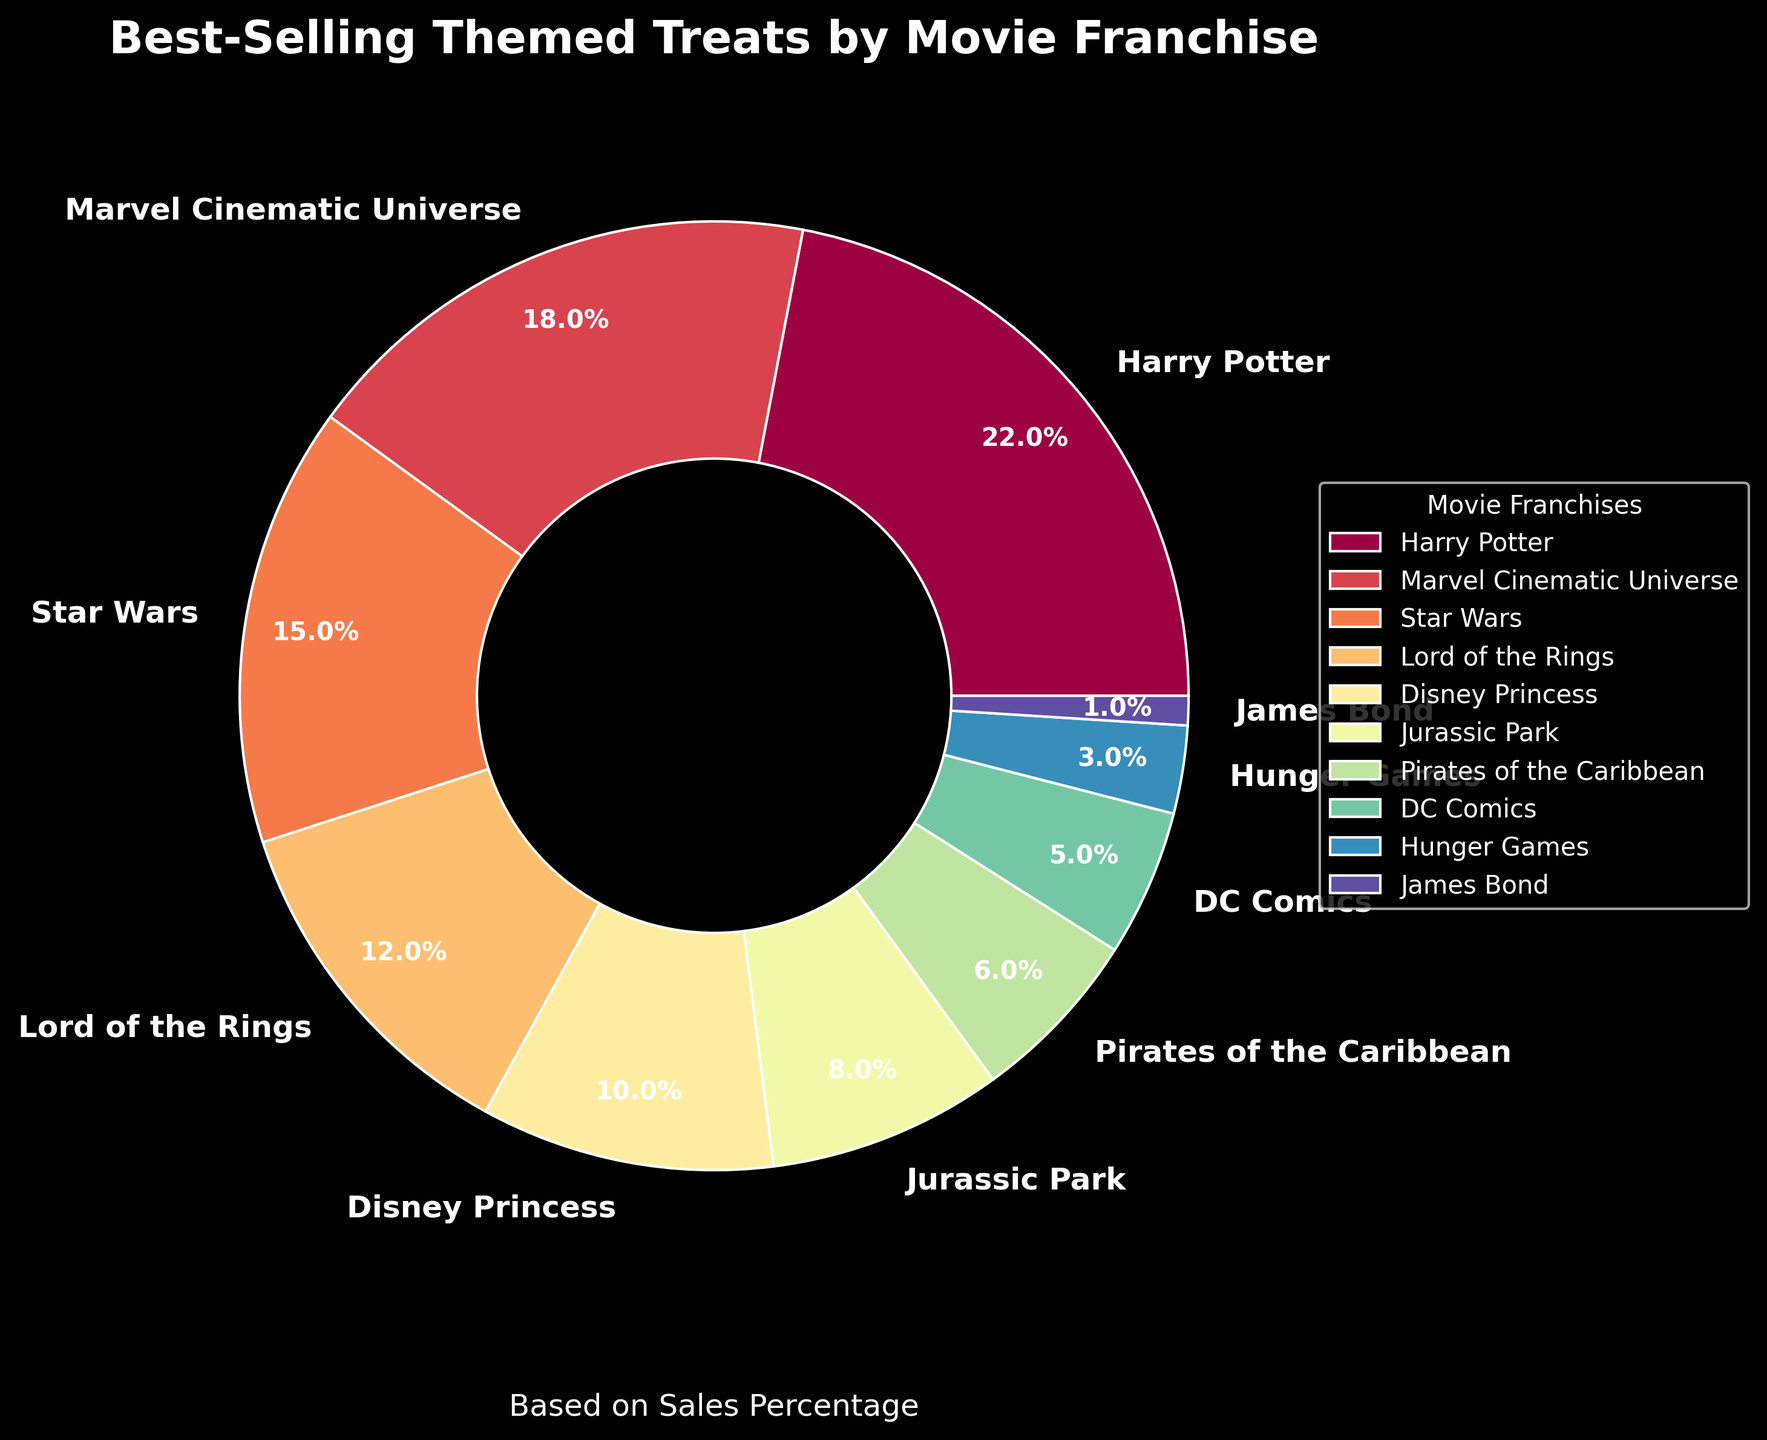Which movie franchise has the highest percentage of best-selling themed treats? The Harry Potter franchise shows the highest percentage in the pie chart, as it occupies the largest wedge.
Answer: Harry Potter Which franchise sells more themed treats, Marvel Cinematic Universe or Star Wars? By observing the size of the wedges in the pie chart, it is clear that the Marvel Cinematic Universe has a larger wedge (18%) than Star Wars (15%).
Answer: Marvel Cinematic Universe What is the combined sales percentage of treats for Disney Princess and Hunger Games? The sales percentage for Disney Princess is 10%, and for Hunger Games, it is 3%. Adding them together, the combined sales percentage is 10% + 3% = 13%.
Answer: 13% Is the sales percentage of Jurassic Park greater than or less than 10%? The pie chart shows that Jurassic Park has a wedge labeled with 8%, which is less than 10%.
Answer: Less than 10% Which franchise has the smallest share of best-selling themed treats, and what is its percentage? The smallest wedge on the pie chart represents the James Bond franchise, with a percentage of 1%.
Answer: James Bond, 1% What are the top three franchises with the highest sales percentages of themed treats? Observing the three largest wedges on the pie chart, the top three franchises are Harry Potter (22%), Marvel Cinematic Universe (18%), and Star Wars (15%).
Answer: Harry Potter, Marvel Cinematic Universe, Star Wars How much more significant is the Harry Potter franchise's sales percentage compared to DC Comics? Harry Potter has a sales percentage of 22%, while DC Comics has 5%. The difference is 22% - 5% = 17%.
Answer: 17% Is the color representing Pirates of the Caribbean closer to the color representing Jurassic Park or Disney Princess? Both Jurassic Park and Pirates of the Caribbean are closer in color on the spectral scale used for the wedges compared to the brighter and more distinct color used for Disney Princess.
Answer: Jurassic Park Which two franchises combined have approximately the same sales percentage as Harry Potter? Combining Lord of the Rings (12%) and Disney Princess (10%) gives 12% + 10% = 22%, which matches Harry Potter's 22%.
Answer: Lord of the Rings and Disney Princess In terms of wedge size, how does DC Comics compare to Pirates of the Caribbean? The wedge representing DC Comics (5%) is slightly smaller than the wedge representing Pirates of the Caribbean (6%).
Answer: Smaller 